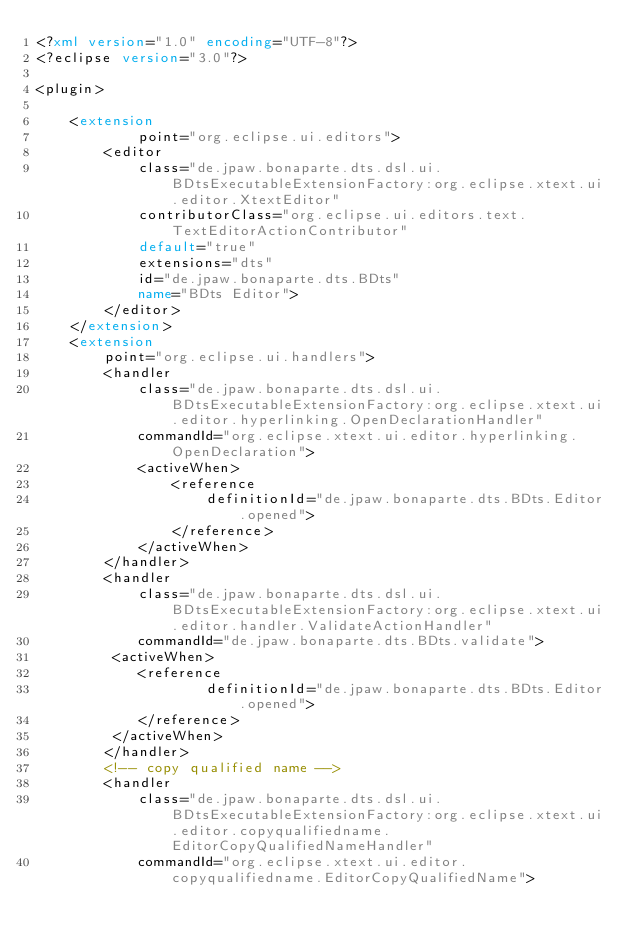<code> <loc_0><loc_0><loc_500><loc_500><_XML_><?xml version="1.0" encoding="UTF-8"?>
<?eclipse version="3.0"?>

<plugin>

    <extension
            point="org.eclipse.ui.editors">
        <editor
            class="de.jpaw.bonaparte.dts.dsl.ui.BDtsExecutableExtensionFactory:org.eclipse.xtext.ui.editor.XtextEditor"
            contributorClass="org.eclipse.ui.editors.text.TextEditorActionContributor"
            default="true"
            extensions="dts"
            id="de.jpaw.bonaparte.dts.BDts"
            name="BDts Editor">
        </editor>
    </extension>
    <extension
        point="org.eclipse.ui.handlers">
        <handler
            class="de.jpaw.bonaparte.dts.dsl.ui.BDtsExecutableExtensionFactory:org.eclipse.xtext.ui.editor.hyperlinking.OpenDeclarationHandler"
            commandId="org.eclipse.xtext.ui.editor.hyperlinking.OpenDeclaration">
            <activeWhen>
                <reference
                    definitionId="de.jpaw.bonaparte.dts.BDts.Editor.opened">
                </reference>
            </activeWhen>
        </handler>
        <handler
            class="de.jpaw.bonaparte.dts.dsl.ui.BDtsExecutableExtensionFactory:org.eclipse.xtext.ui.editor.handler.ValidateActionHandler"
            commandId="de.jpaw.bonaparte.dts.BDts.validate">
         <activeWhen>
            <reference
                    definitionId="de.jpaw.bonaparte.dts.BDts.Editor.opened">
            </reference>
         </activeWhen>
        </handler>
        <!-- copy qualified name -->
        <handler
            class="de.jpaw.bonaparte.dts.dsl.ui.BDtsExecutableExtensionFactory:org.eclipse.xtext.ui.editor.copyqualifiedname.EditorCopyQualifiedNameHandler"
            commandId="org.eclipse.xtext.ui.editor.copyqualifiedname.EditorCopyQualifiedName"></code> 